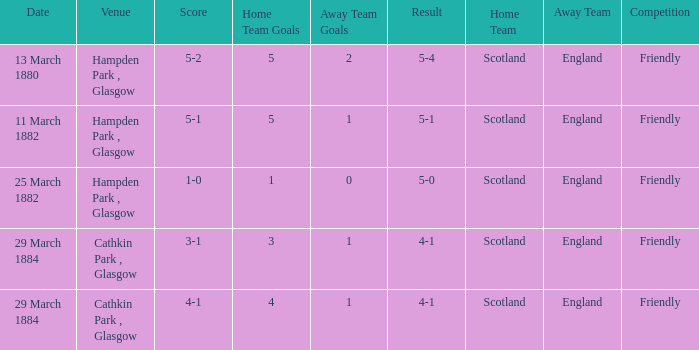Which item resulted in a score of 4-1? 3-1, 4-1. 